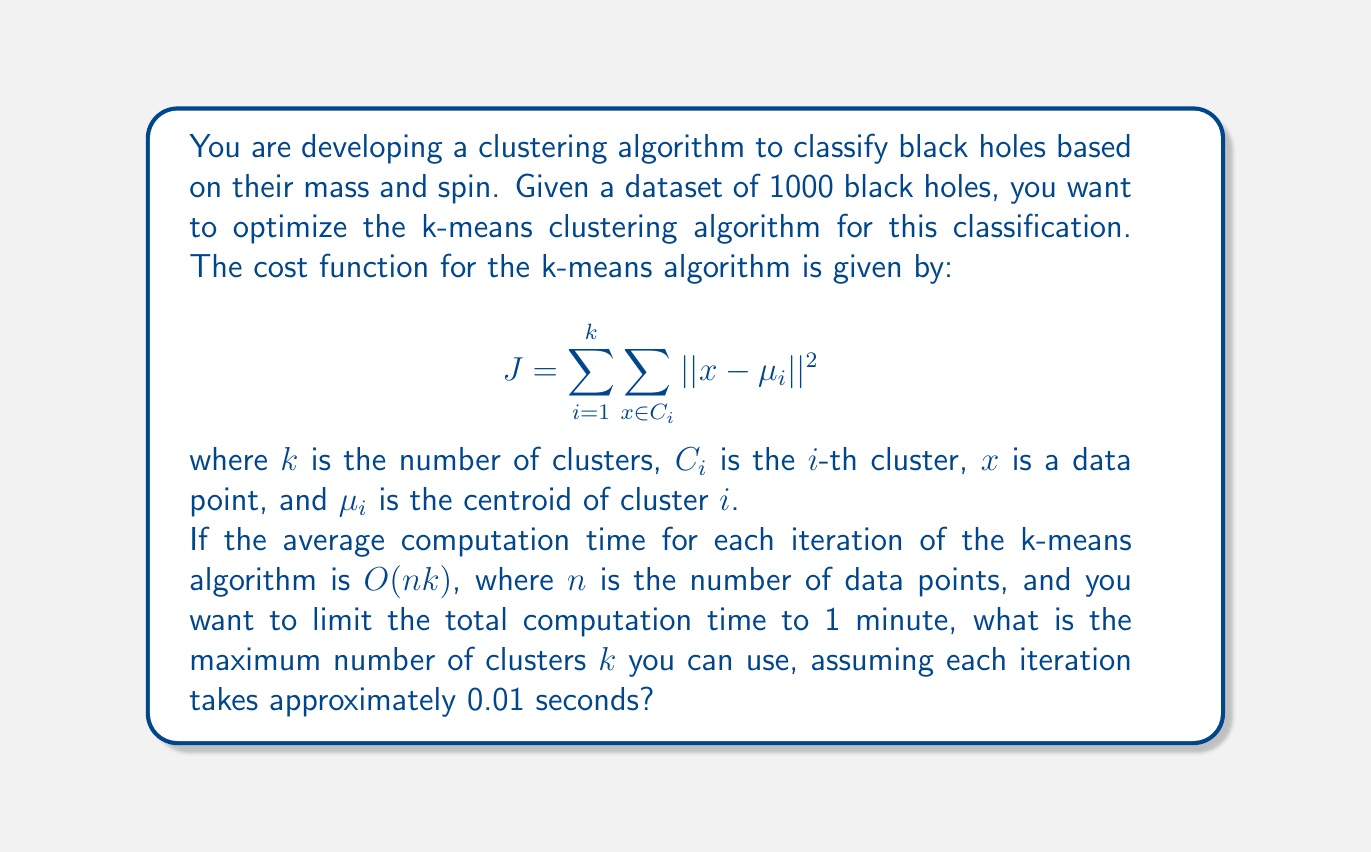Help me with this question. To solve this problem, we need to follow these steps:

1. Understand the given information:
   - Total number of data points (black holes): $n = 1000$
   - Time limit: 1 minute = 60 seconds
   - Time per iteration: 0.01 seconds

2. Calculate the maximum number of iterations possible within the time limit:
   $$ \text{Max iterations} = \frac{\text{Time limit}}{\text{Time per iteration}} = \frac{60}{0.01} = 6000 \text{ iterations} $$

3. Use the time complexity formula $O(nk)$ to set up an equation:
   $$ nk \cdot 6000 = 60 \text{ seconds} $$
   
   This equation represents that the total computation time (left side) should equal the time limit (right side).

4. Substitute the known values:
   $$ 1000k \cdot 6000 = 60 \text{ seconds} $$

5. Solve for $k$:
   $$ 6,000,000k = 60 $$
   $$ k = \frac{60}{6,000,000} = 0.00001 $$

6. Since $k$ represents the number of clusters and must be a positive integer, we round down to the nearest whole number:
   $$ k = \lfloor 0.00001 \rfloor = 1 $$

However, using only one cluster defeats the purpose of clustering. In practice, we would need to adjust our constraints (e.g., allow more time, use a faster computer, or implement a more efficient algorithm) to allow for a meaningful number of clusters.
Answer: The maximum number of clusters $k$ that can be used within the given time constraint is 1. However, this result indicates that the time constraint is too strict for meaningful clustering with the given dataset size and algorithm complexity. 